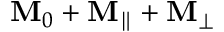<formula> <loc_0><loc_0><loc_500><loc_500>M _ { 0 } + M _ { \| } + M _ { \perp }</formula> 